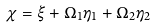Convert formula to latex. <formula><loc_0><loc_0><loc_500><loc_500>\chi = \xi + \Omega _ { 1 } \eta _ { 1 } + \Omega _ { 2 } \eta _ { 2 }</formula> 